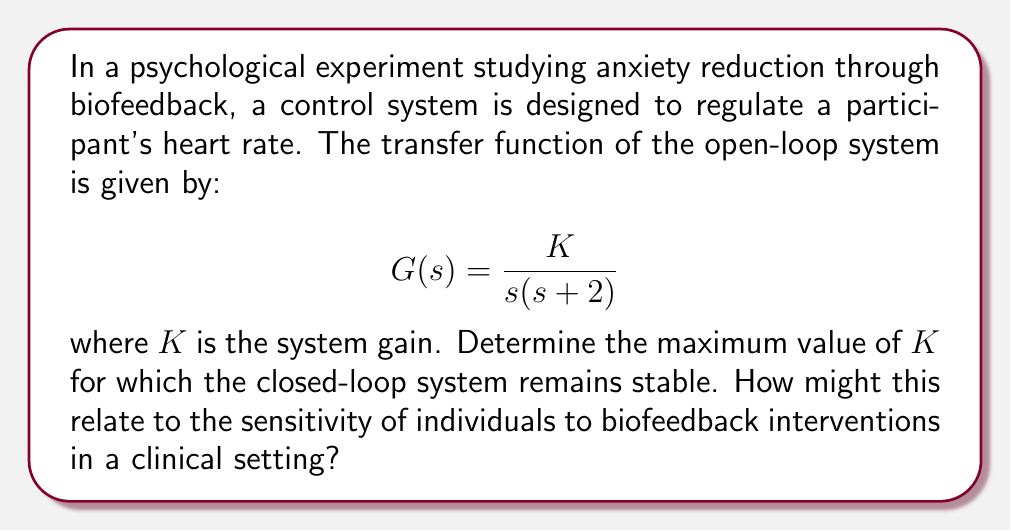What is the answer to this math problem? To analyze the stability of this closed-loop control system, we'll use the Routh-Hurwitz stability criterion. This method is particularly relevant in control theory and can be applied to psychological experiments involving feedback mechanisms.

1. First, we need to determine the characteristic equation of the closed-loop system. The closed-loop transfer function is:

   $$H(s) = \frac{G(s)}{1 + G(s)} = \frac{K}{s^2 + 2s + K}$$

2. The characteristic equation is the denominator of $H(s)$ set to zero:

   $$s^2 + 2s + K = 0$$

3. Now, we construct the Routh array:

   $$\begin{array}{c|cc}
   s^2 & 1 & K \\
   s^1 & 2 & 0 \\
   s^0 & K & 0
   \end{array}$$

4. For the system to be stable, all elements in the first column of the Routh array must be positive. We already know that the first two elements (1 and 2) are positive. The third element, $K$, must also be positive.

5. The maximum value of $K$ for stability occurs when the system is on the verge of instability. This happens when the last row of the Routh array becomes zero:

   $$K = 0$$

6. Solving this equation, we find that the maximum value of $K$ for stability is:

   $$K_{max} = 4$$

In the context of a clinical psychology setting, this result suggests that there's a limit to how sensitive the biofeedback system can be before it becomes unstable. A higher $K$ value represents a more responsive system, but if it's too high (above 4 in this case), the system may overreact to small changes in heart rate, potentially causing anxiety rather than reducing it. This relates to the importance of calibrating biofeedback interventions to an individual's specific responsiveness, ensuring the feedback is effective without being overwhelming.
Answer: The maximum value of $K$ for which the closed-loop system remains stable is 4. 